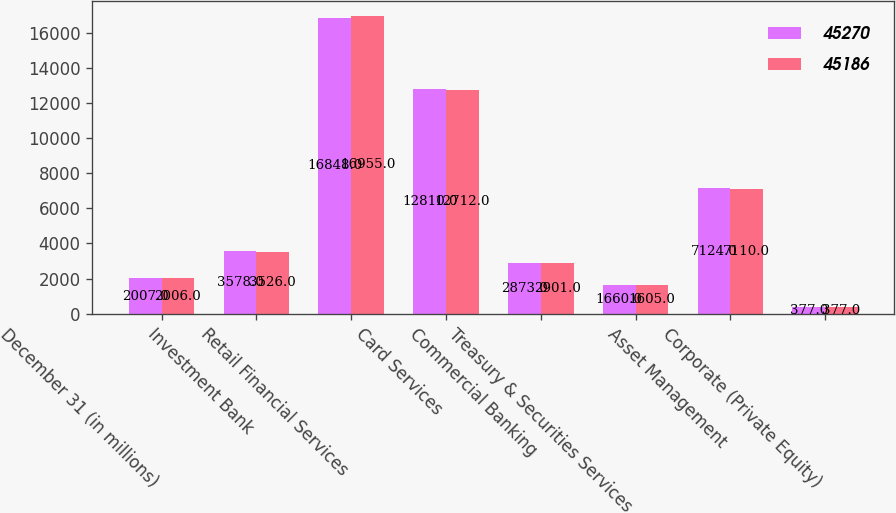<chart> <loc_0><loc_0><loc_500><loc_500><stacked_bar_chart><ecel><fcel>December 31 (in millions)<fcel>Investment Bank<fcel>Retail Financial Services<fcel>Card Services<fcel>Commercial Banking<fcel>Treasury & Securities Services<fcel>Asset Management<fcel>Corporate (Private Equity)<nl><fcel>45270<fcel>2007<fcel>3578<fcel>16848<fcel>12810<fcel>2873<fcel>1660<fcel>7124<fcel>377<nl><fcel>45186<fcel>2006<fcel>3526<fcel>16955<fcel>12712<fcel>2901<fcel>1605<fcel>7110<fcel>377<nl></chart> 